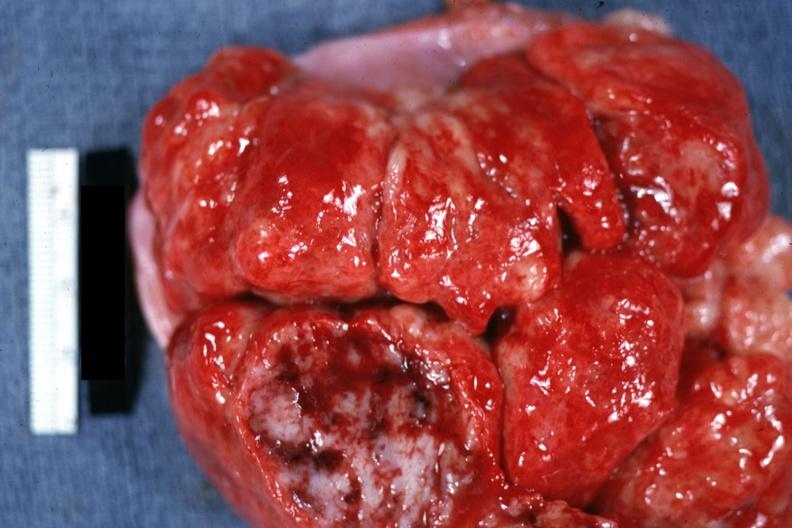what does this image show?
Answer the question using a single word or phrase. Massive enlargement with necrosis shown close-up natural color 